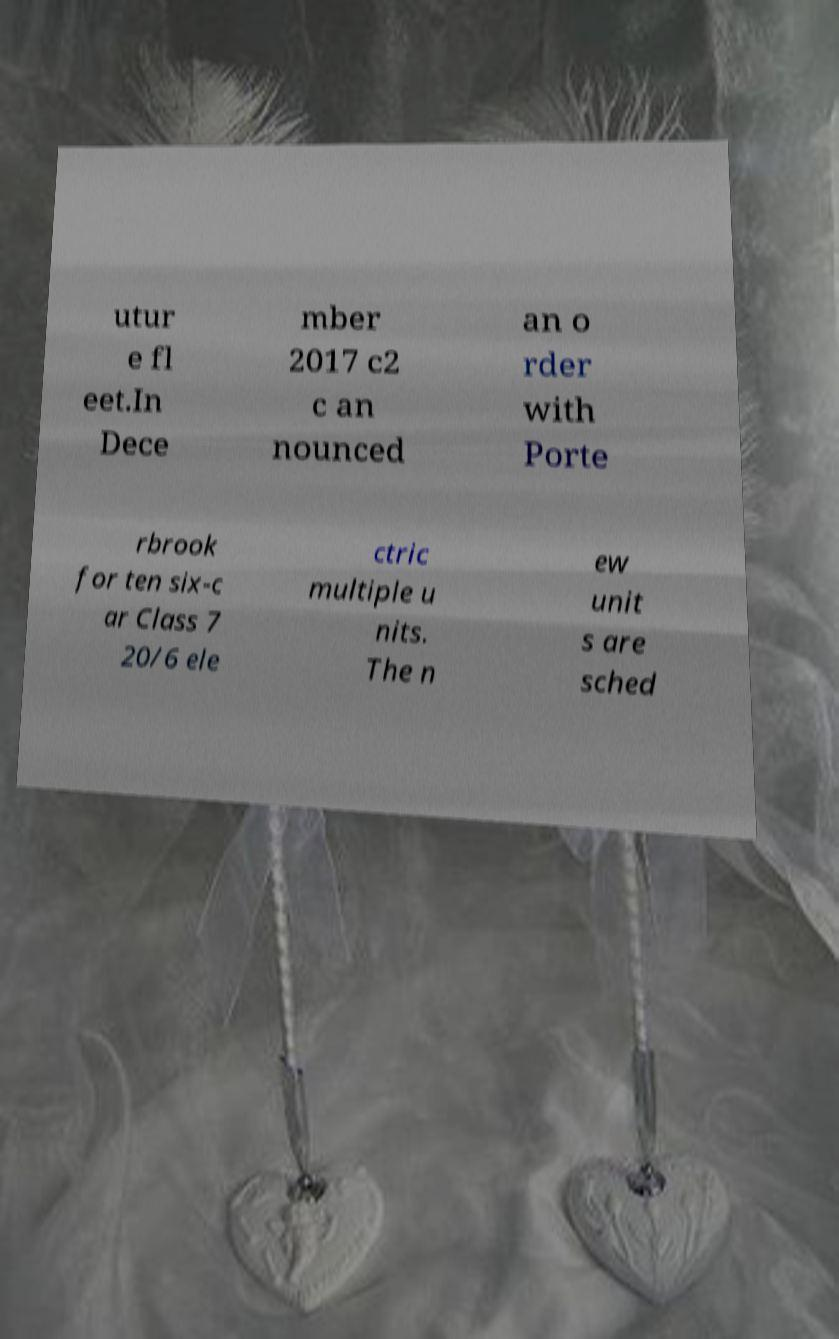Please identify and transcribe the text found in this image. utur e fl eet.In Dece mber 2017 c2 c an nounced an o rder with Porte rbrook for ten six-c ar Class 7 20/6 ele ctric multiple u nits. The n ew unit s are sched 